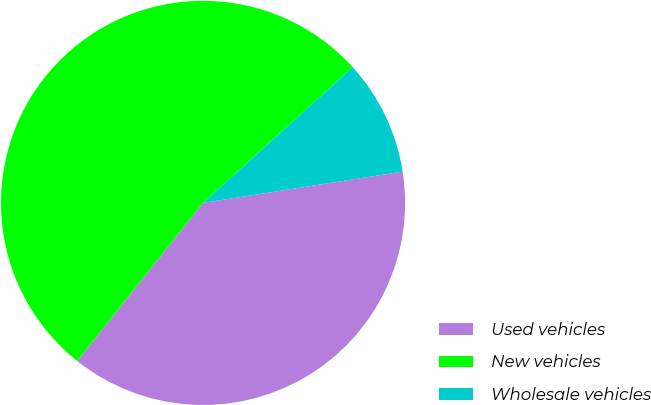<chart> <loc_0><loc_0><loc_500><loc_500><pie_chart><fcel>Used vehicles<fcel>New vehicles<fcel>Wholesale vehicles<nl><fcel>38.18%<fcel>52.57%<fcel>9.25%<nl></chart> 